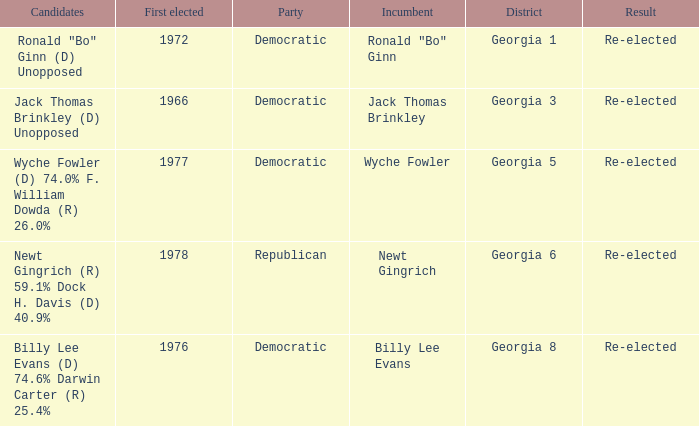What is the earliest first elected for district georgia 1? 1972.0. 